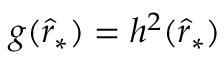<formula> <loc_0><loc_0><loc_500><loc_500>\begin{array} { r } { g ( \hat { r } _ { * } ) = h ^ { 2 } ( \hat { r } _ { * } ) } \end{array}</formula> 